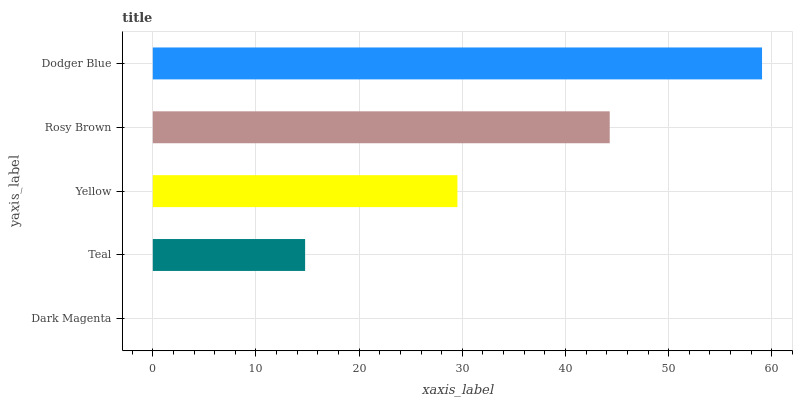Is Dark Magenta the minimum?
Answer yes or no. Yes. Is Dodger Blue the maximum?
Answer yes or no. Yes. Is Teal the minimum?
Answer yes or no. No. Is Teal the maximum?
Answer yes or no. No. Is Teal greater than Dark Magenta?
Answer yes or no. Yes. Is Dark Magenta less than Teal?
Answer yes or no. Yes. Is Dark Magenta greater than Teal?
Answer yes or no. No. Is Teal less than Dark Magenta?
Answer yes or no. No. Is Yellow the high median?
Answer yes or no. Yes. Is Yellow the low median?
Answer yes or no. Yes. Is Dark Magenta the high median?
Answer yes or no. No. Is Dodger Blue the low median?
Answer yes or no. No. 